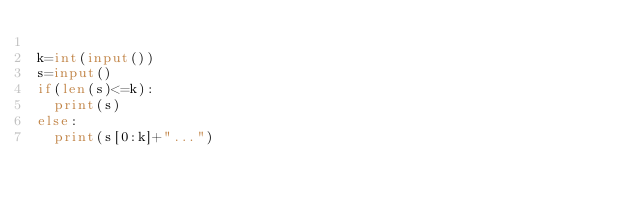Convert code to text. <code><loc_0><loc_0><loc_500><loc_500><_Python_>
k=int(input())
s=input()
if(len(s)<=k):
  print(s)
else:
  print(s[0:k]+"...")</code> 